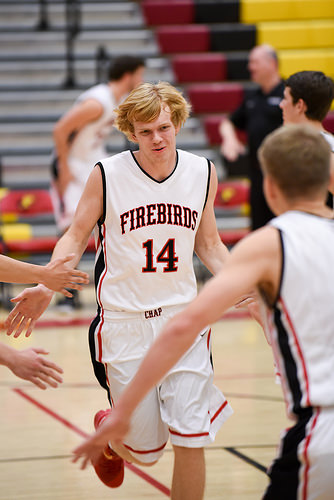<image>
Is there a man next to the man? Yes. The man is positioned adjacent to the man, located nearby in the same general area. 